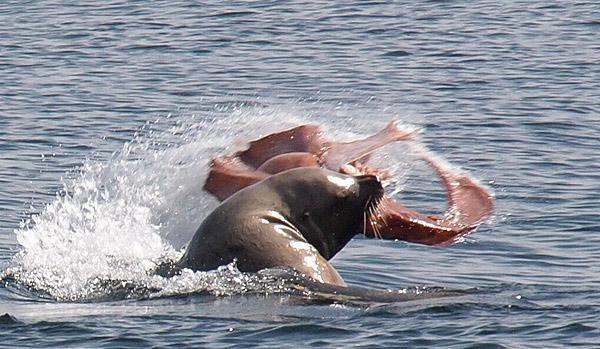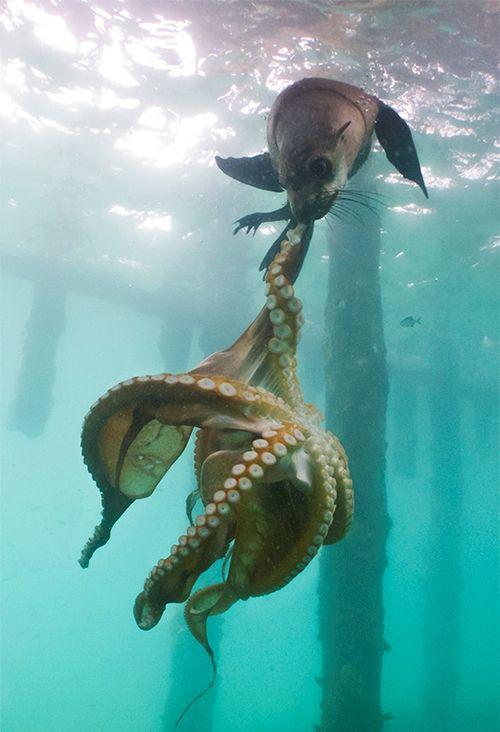The first image is the image on the left, the second image is the image on the right. Analyze the images presented: Is the assertion "Right image shows a seal with its head above water and octopus legs sticking out of its mouth." valid? Answer yes or no. No. 